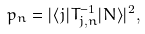<formula> <loc_0><loc_0><loc_500><loc_500>p _ { n } = | \langle j | T _ { j , n } ^ { - 1 } | N \rangle | ^ { 2 } ,</formula> 